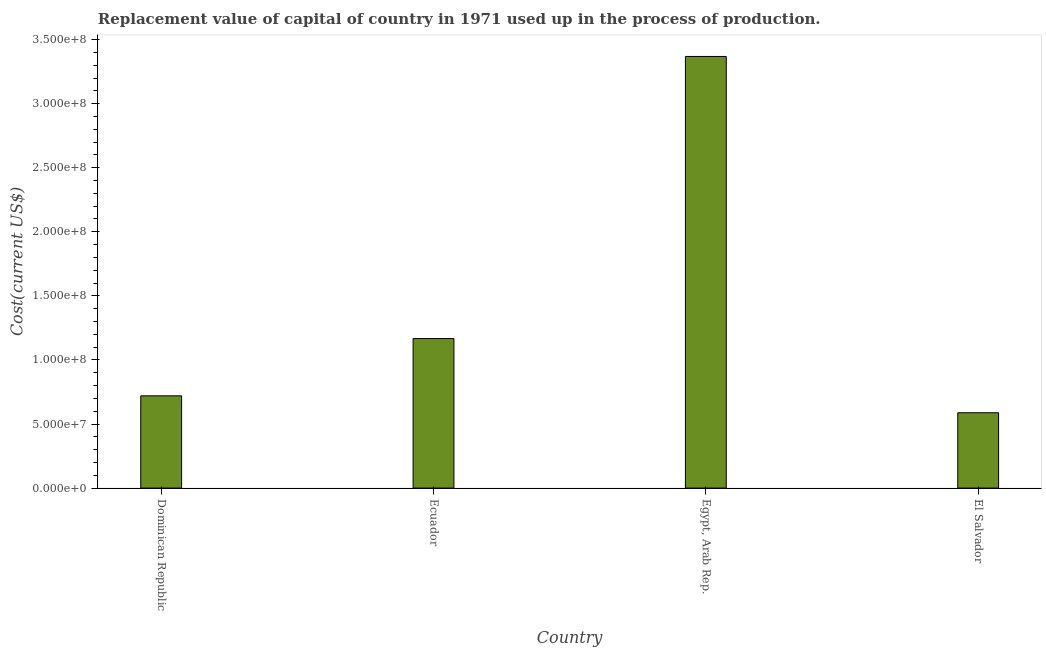Does the graph contain grids?
Your response must be concise. No. What is the title of the graph?
Provide a succinct answer. Replacement value of capital of country in 1971 used up in the process of production. What is the label or title of the X-axis?
Your answer should be very brief. Country. What is the label or title of the Y-axis?
Keep it short and to the point. Cost(current US$). What is the consumption of fixed capital in Egypt, Arab Rep.?
Give a very brief answer. 3.37e+08. Across all countries, what is the maximum consumption of fixed capital?
Your response must be concise. 3.37e+08. Across all countries, what is the minimum consumption of fixed capital?
Your answer should be very brief. 5.88e+07. In which country was the consumption of fixed capital maximum?
Make the answer very short. Egypt, Arab Rep. In which country was the consumption of fixed capital minimum?
Make the answer very short. El Salvador. What is the sum of the consumption of fixed capital?
Offer a terse response. 5.84e+08. What is the difference between the consumption of fixed capital in Ecuador and Egypt, Arab Rep.?
Make the answer very short. -2.20e+08. What is the average consumption of fixed capital per country?
Make the answer very short. 1.46e+08. What is the median consumption of fixed capital?
Offer a very short reply. 9.43e+07. In how many countries, is the consumption of fixed capital greater than 100000000 US$?
Offer a terse response. 2. What is the ratio of the consumption of fixed capital in Dominican Republic to that in Egypt, Arab Rep.?
Provide a succinct answer. 0.21. Is the consumption of fixed capital in Egypt, Arab Rep. less than that in El Salvador?
Your answer should be compact. No. What is the difference between the highest and the second highest consumption of fixed capital?
Your answer should be compact. 2.20e+08. What is the difference between the highest and the lowest consumption of fixed capital?
Give a very brief answer. 2.78e+08. In how many countries, is the consumption of fixed capital greater than the average consumption of fixed capital taken over all countries?
Provide a succinct answer. 1. How many bars are there?
Your answer should be compact. 4. Are all the bars in the graph horizontal?
Provide a succinct answer. No. Are the values on the major ticks of Y-axis written in scientific E-notation?
Ensure brevity in your answer.  Yes. What is the Cost(current US$) in Dominican Republic?
Your response must be concise. 7.20e+07. What is the Cost(current US$) of Ecuador?
Your response must be concise. 1.17e+08. What is the Cost(current US$) in Egypt, Arab Rep.?
Your response must be concise. 3.37e+08. What is the Cost(current US$) in El Salvador?
Offer a terse response. 5.88e+07. What is the difference between the Cost(current US$) in Dominican Republic and Ecuador?
Offer a very short reply. -4.47e+07. What is the difference between the Cost(current US$) in Dominican Republic and Egypt, Arab Rep.?
Keep it short and to the point. -2.65e+08. What is the difference between the Cost(current US$) in Dominican Republic and El Salvador?
Give a very brief answer. 1.32e+07. What is the difference between the Cost(current US$) in Ecuador and Egypt, Arab Rep.?
Make the answer very short. -2.20e+08. What is the difference between the Cost(current US$) in Ecuador and El Salvador?
Provide a succinct answer. 5.79e+07. What is the difference between the Cost(current US$) in Egypt, Arab Rep. and El Salvador?
Give a very brief answer. 2.78e+08. What is the ratio of the Cost(current US$) in Dominican Republic to that in Ecuador?
Your response must be concise. 0.62. What is the ratio of the Cost(current US$) in Dominican Republic to that in Egypt, Arab Rep.?
Give a very brief answer. 0.21. What is the ratio of the Cost(current US$) in Dominican Republic to that in El Salvador?
Offer a terse response. 1.23. What is the ratio of the Cost(current US$) in Ecuador to that in Egypt, Arab Rep.?
Make the answer very short. 0.35. What is the ratio of the Cost(current US$) in Ecuador to that in El Salvador?
Provide a succinct answer. 1.99. What is the ratio of the Cost(current US$) in Egypt, Arab Rep. to that in El Salvador?
Your response must be concise. 5.73. 